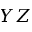<formula> <loc_0><loc_0><loc_500><loc_500>Y Z</formula> 